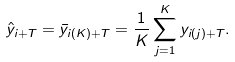<formula> <loc_0><loc_0><loc_500><loc_500>\hat { y } _ { i + T } = \bar { y } _ { i ( K ) + T } = \frac { 1 } { K } \sum _ { j = 1 } ^ { K } y _ { i ( j ) + T } .</formula> 